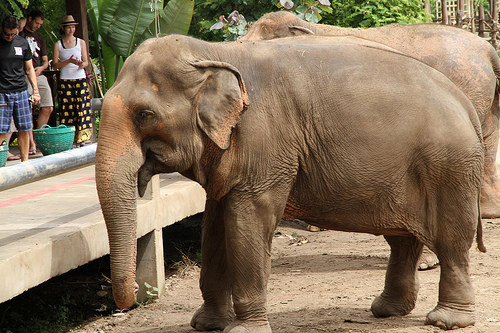Is there a hippo behind the floor? No, there is no hippo behind the floor; instead, there is an elephant. 